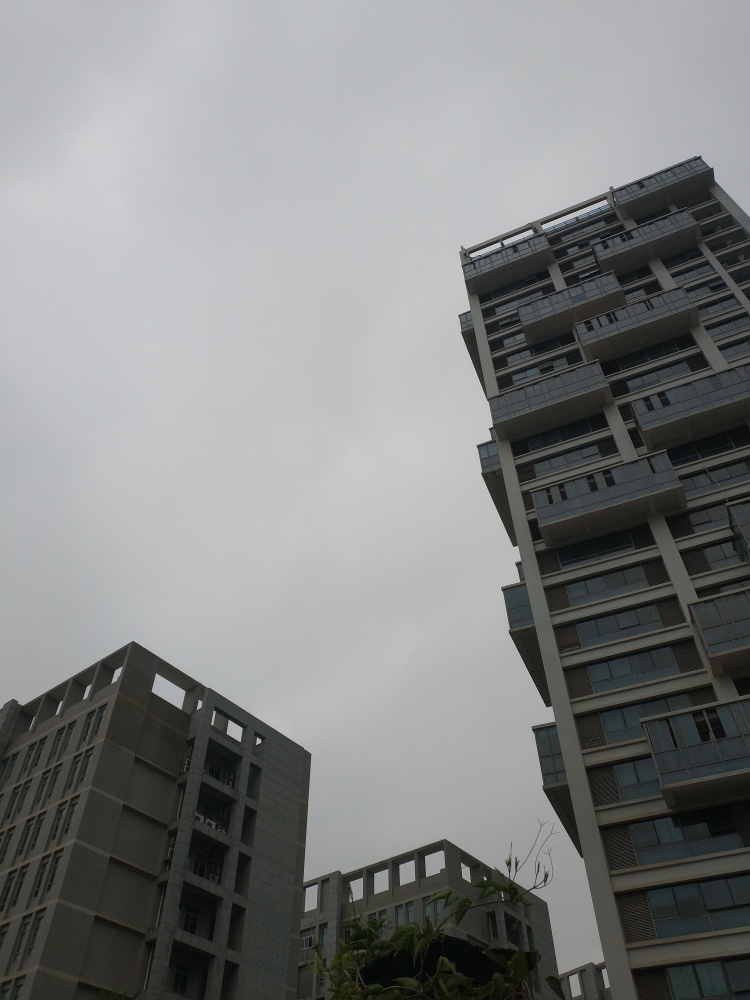What is the weather like in the picture, and how might it affect someone's mood? The weather in the image is overcast, and the sky is filled with grey clouds. Such conditions can often lead to a somber or calm mood, potentially matching the quietness of the scene depicted. People might feel more reflective or subdued on days like this. 